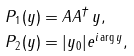Convert formula to latex. <formula><loc_0><loc_0><loc_500><loc_500>P _ { 1 } ( y ) & = A A ^ { \dag } \, y , \\ P _ { 2 } ( y ) & = | y _ { 0 } | e ^ { i \arg { y } } ,</formula> 